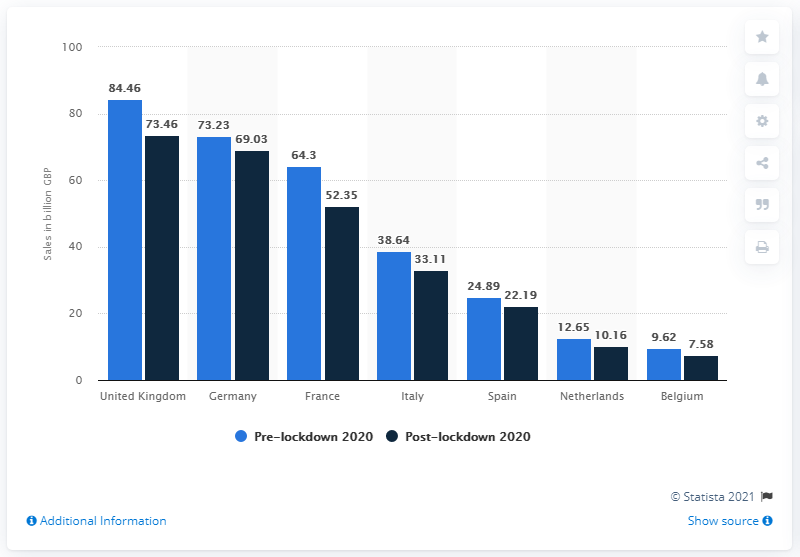Mention a couple of crucial points in this snapshot. The total of the Netherlands' combined blue and dark blue bars is 22.81. According to the pre-lockdown data in 2020, Germany had a reported figure of 73.23 cases of cases of confirmed COVID-19 cases. 